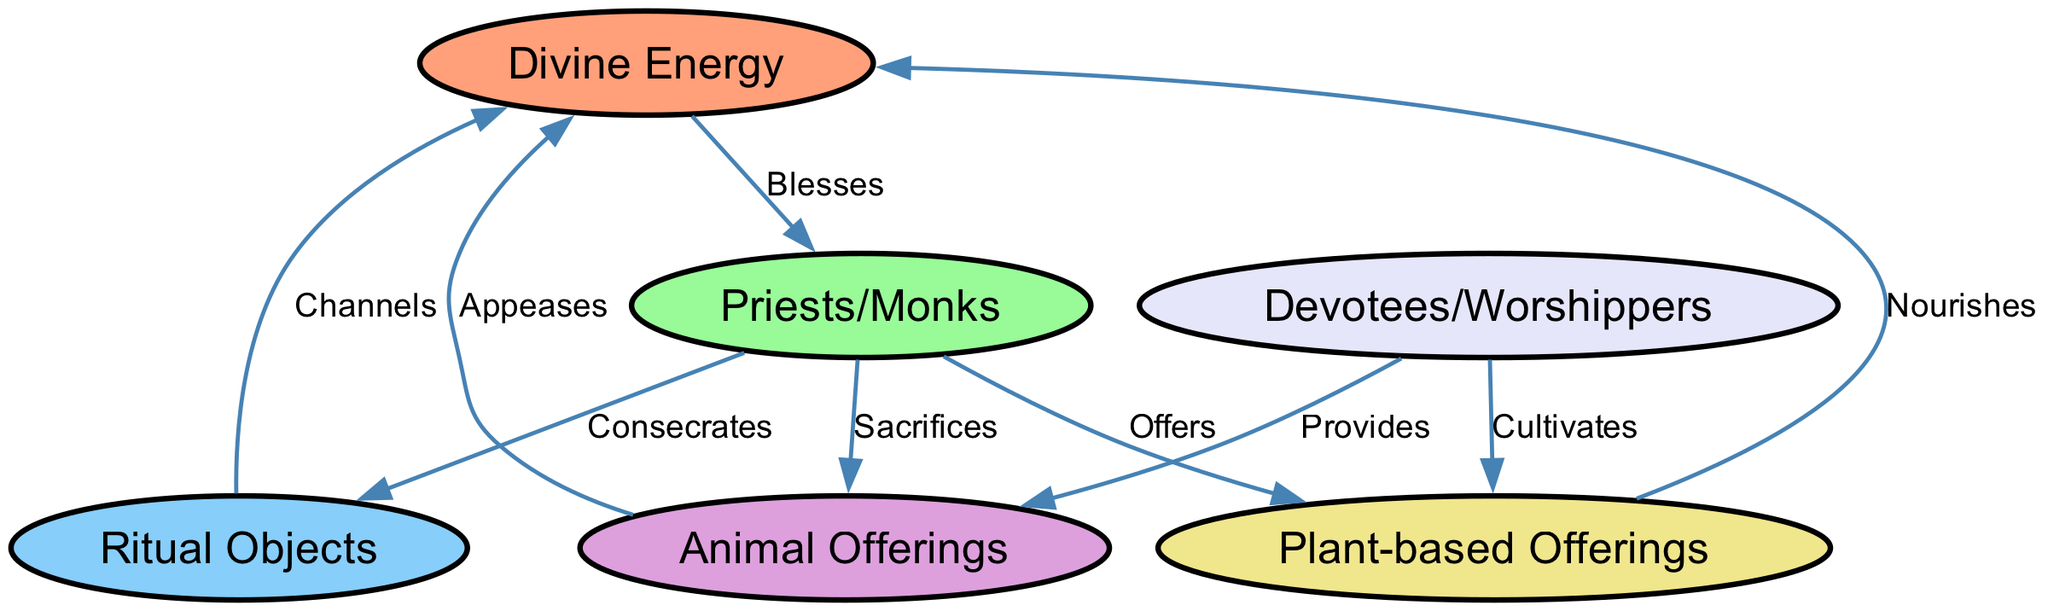What is the number of nodes in the diagram? The diagram lists six distinct nodes: Divine Energy, Priests/Monks, Ritual Objects, Animal Offerings, Plant-based Offerings, and Devotees/Worshippers.
Answer: 6 Which node provides Animal Offerings? According to the diagram, the arrow labeled "Provides" points from Devotees/Worshippers to Animal Offerings, indicating that this is the source of Animal Offerings.
Answer: Devotees/Worshippers What action do Priests/Monks perform towards Ritual Objects? The edge labeled "Consecrates" connects the nodes Priests/Monks and Ritual Objects, indicating that Priests/Monks are responsible for the action of consecration.
Answer: Consecrates How many edges are present in the diagram? By counting the edges connecting the nodes, there are a total of eight edges represented in the diagram.
Answer: 8 What is the relationship between Animal Offerings and Divine Energy? The diagram shows that the edge labeled "Appeases" goes from Animal Offerings to Divine Energy, indicating that Animal Offerings serve to appease the Divine Energy.
Answer: Appeases What type of offerings do Devotees/Worshippers cultivate? According to the diagram, there is an edge labeled "Cultivates" from Devotees/Worshippers to Plant-based Offerings, indicating that they are responsible for cultivating this type of offering.
Answer: Plant-based Offerings Which node channels Divine Energy? The edge labeled "Channels" connects the Ritual Objects to Divine Energy, indicating that Ritual Objects serve the purpose of channeling Divine Energy.
Answer: Ritual Objects What do Priests/Monks do with Plant-based Offerings? The edge labeled "Offers" connects Priests/Monks to Plant-based Offerings, indicating that they offer these to the Divine Energy.
Answer: Offers 